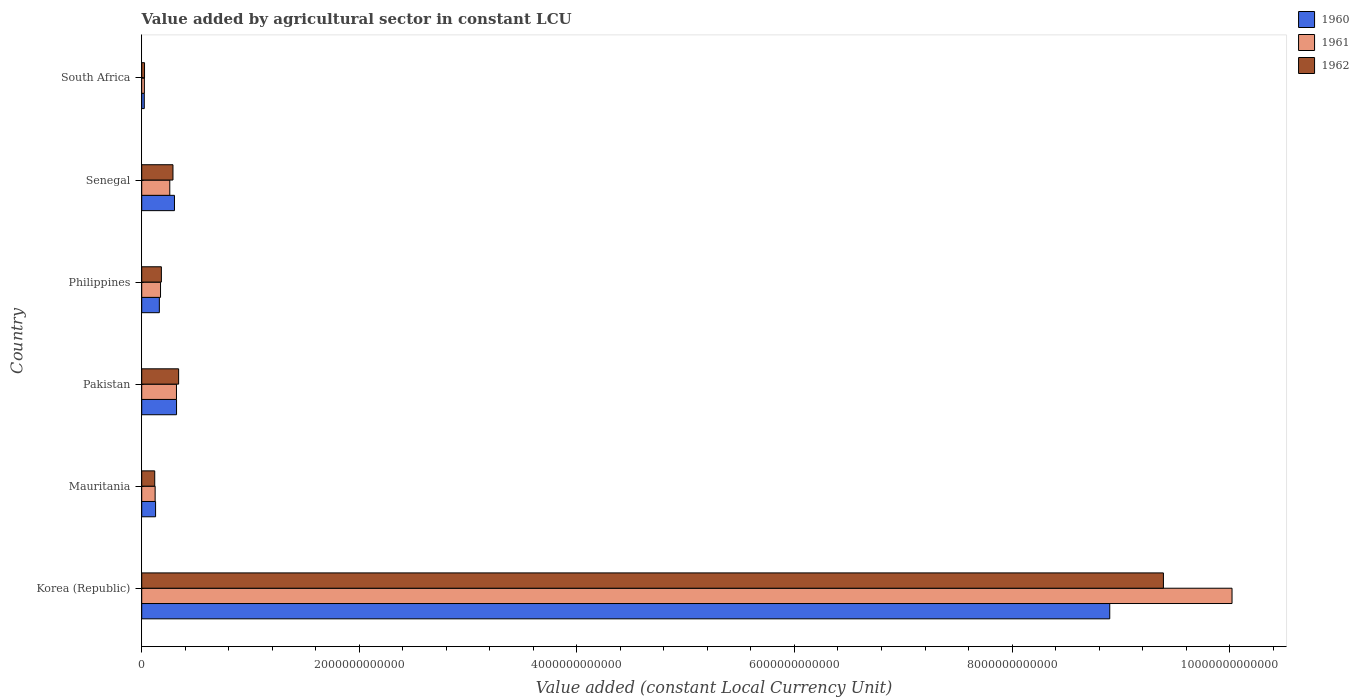How many different coloured bars are there?
Provide a short and direct response. 3. Are the number of bars per tick equal to the number of legend labels?
Offer a terse response. Yes. Are the number of bars on each tick of the Y-axis equal?
Offer a very short reply. Yes. How many bars are there on the 6th tick from the top?
Make the answer very short. 3. What is the label of the 6th group of bars from the top?
Offer a terse response. Korea (Republic). In how many cases, is the number of bars for a given country not equal to the number of legend labels?
Offer a terse response. 0. What is the value added by agricultural sector in 1960 in South Africa?
Offer a terse response. 2.36e+1. Across all countries, what is the maximum value added by agricultural sector in 1960?
Provide a short and direct response. 8.90e+12. Across all countries, what is the minimum value added by agricultural sector in 1962?
Offer a very short reply. 2.58e+1. In which country was the value added by agricultural sector in 1961 maximum?
Offer a very short reply. Korea (Republic). In which country was the value added by agricultural sector in 1961 minimum?
Provide a succinct answer. South Africa. What is the total value added by agricultural sector in 1962 in the graph?
Offer a very short reply. 1.03e+13. What is the difference between the value added by agricultural sector in 1961 in Korea (Republic) and that in Philippines?
Provide a short and direct response. 9.85e+12. What is the difference between the value added by agricultural sector in 1962 in Pakistan and the value added by agricultural sector in 1960 in Senegal?
Give a very brief answer. 3.82e+1. What is the average value added by agricultural sector in 1961 per country?
Your answer should be very brief. 1.82e+12. What is the difference between the value added by agricultural sector in 1960 and value added by agricultural sector in 1962 in Korea (Republic)?
Make the answer very short. -4.93e+11. In how many countries, is the value added by agricultural sector in 1961 greater than 7200000000000 LCU?
Offer a very short reply. 1. What is the ratio of the value added by agricultural sector in 1962 in Philippines to that in South Africa?
Provide a short and direct response. 7. Is the value added by agricultural sector in 1961 in Korea (Republic) less than that in Mauritania?
Provide a short and direct response. No. What is the difference between the highest and the second highest value added by agricultural sector in 1961?
Offer a terse response. 9.70e+12. What is the difference between the highest and the lowest value added by agricultural sector in 1962?
Offer a very short reply. 9.37e+12. What does the 1st bar from the top in Philippines represents?
Your answer should be compact. 1962. What does the 2nd bar from the bottom in Korea (Republic) represents?
Provide a succinct answer. 1961. Is it the case that in every country, the sum of the value added by agricultural sector in 1961 and value added by agricultural sector in 1960 is greater than the value added by agricultural sector in 1962?
Give a very brief answer. Yes. How many bars are there?
Provide a short and direct response. 18. Are all the bars in the graph horizontal?
Make the answer very short. Yes. How many countries are there in the graph?
Your answer should be very brief. 6. What is the difference between two consecutive major ticks on the X-axis?
Ensure brevity in your answer.  2.00e+12. Does the graph contain grids?
Offer a very short reply. No. What is the title of the graph?
Provide a short and direct response. Value added by agricultural sector in constant LCU. Does "1972" appear as one of the legend labels in the graph?
Your response must be concise. No. What is the label or title of the X-axis?
Offer a very short reply. Value added (constant Local Currency Unit). What is the Value added (constant Local Currency Unit) in 1960 in Korea (Republic)?
Offer a terse response. 8.90e+12. What is the Value added (constant Local Currency Unit) in 1961 in Korea (Republic)?
Your response must be concise. 1.00e+13. What is the Value added (constant Local Currency Unit) in 1962 in Korea (Republic)?
Provide a succinct answer. 9.39e+12. What is the Value added (constant Local Currency Unit) of 1960 in Mauritania?
Make the answer very short. 1.27e+11. What is the Value added (constant Local Currency Unit) of 1961 in Mauritania?
Give a very brief answer. 1.23e+11. What is the Value added (constant Local Currency Unit) of 1962 in Mauritania?
Ensure brevity in your answer.  1.20e+11. What is the Value added (constant Local Currency Unit) in 1960 in Pakistan?
Give a very brief answer. 3.20e+11. What is the Value added (constant Local Currency Unit) of 1961 in Pakistan?
Make the answer very short. 3.19e+11. What is the Value added (constant Local Currency Unit) of 1962 in Pakistan?
Provide a short and direct response. 3.39e+11. What is the Value added (constant Local Currency Unit) of 1960 in Philippines?
Ensure brevity in your answer.  1.62e+11. What is the Value added (constant Local Currency Unit) of 1961 in Philippines?
Your answer should be compact. 1.73e+11. What is the Value added (constant Local Currency Unit) of 1962 in Philippines?
Give a very brief answer. 1.81e+11. What is the Value added (constant Local Currency Unit) in 1960 in Senegal?
Your response must be concise. 3.01e+11. What is the Value added (constant Local Currency Unit) of 1961 in Senegal?
Offer a very short reply. 2.58e+11. What is the Value added (constant Local Currency Unit) of 1962 in Senegal?
Give a very brief answer. 2.87e+11. What is the Value added (constant Local Currency Unit) of 1960 in South Africa?
Your response must be concise. 2.36e+1. What is the Value added (constant Local Currency Unit) of 1961 in South Africa?
Your response must be concise. 2.44e+1. What is the Value added (constant Local Currency Unit) in 1962 in South Africa?
Keep it short and to the point. 2.58e+1. Across all countries, what is the maximum Value added (constant Local Currency Unit) in 1960?
Keep it short and to the point. 8.90e+12. Across all countries, what is the maximum Value added (constant Local Currency Unit) of 1961?
Provide a succinct answer. 1.00e+13. Across all countries, what is the maximum Value added (constant Local Currency Unit) in 1962?
Your response must be concise. 9.39e+12. Across all countries, what is the minimum Value added (constant Local Currency Unit) of 1960?
Keep it short and to the point. 2.36e+1. Across all countries, what is the minimum Value added (constant Local Currency Unit) in 1961?
Keep it short and to the point. 2.44e+1. Across all countries, what is the minimum Value added (constant Local Currency Unit) of 1962?
Offer a terse response. 2.58e+1. What is the total Value added (constant Local Currency Unit) in 1960 in the graph?
Offer a very short reply. 9.83e+12. What is the total Value added (constant Local Currency Unit) of 1961 in the graph?
Make the answer very short. 1.09e+13. What is the total Value added (constant Local Currency Unit) in 1962 in the graph?
Keep it short and to the point. 1.03e+13. What is the difference between the Value added (constant Local Currency Unit) of 1960 in Korea (Republic) and that in Mauritania?
Ensure brevity in your answer.  8.77e+12. What is the difference between the Value added (constant Local Currency Unit) of 1961 in Korea (Republic) and that in Mauritania?
Make the answer very short. 9.90e+12. What is the difference between the Value added (constant Local Currency Unit) in 1962 in Korea (Republic) and that in Mauritania?
Provide a succinct answer. 9.27e+12. What is the difference between the Value added (constant Local Currency Unit) in 1960 in Korea (Republic) and that in Pakistan?
Your answer should be very brief. 8.58e+12. What is the difference between the Value added (constant Local Currency Unit) in 1961 in Korea (Republic) and that in Pakistan?
Your answer should be compact. 9.70e+12. What is the difference between the Value added (constant Local Currency Unit) in 1962 in Korea (Republic) and that in Pakistan?
Give a very brief answer. 9.05e+12. What is the difference between the Value added (constant Local Currency Unit) in 1960 in Korea (Republic) and that in Philippines?
Keep it short and to the point. 8.74e+12. What is the difference between the Value added (constant Local Currency Unit) in 1961 in Korea (Republic) and that in Philippines?
Offer a terse response. 9.85e+12. What is the difference between the Value added (constant Local Currency Unit) in 1962 in Korea (Republic) and that in Philippines?
Provide a succinct answer. 9.21e+12. What is the difference between the Value added (constant Local Currency Unit) of 1960 in Korea (Republic) and that in Senegal?
Your answer should be very brief. 8.60e+12. What is the difference between the Value added (constant Local Currency Unit) in 1961 in Korea (Republic) and that in Senegal?
Provide a short and direct response. 9.76e+12. What is the difference between the Value added (constant Local Currency Unit) in 1962 in Korea (Republic) and that in Senegal?
Give a very brief answer. 9.10e+12. What is the difference between the Value added (constant Local Currency Unit) of 1960 in Korea (Republic) and that in South Africa?
Provide a succinct answer. 8.87e+12. What is the difference between the Value added (constant Local Currency Unit) of 1961 in Korea (Republic) and that in South Africa?
Your answer should be very brief. 1.00e+13. What is the difference between the Value added (constant Local Currency Unit) in 1962 in Korea (Republic) and that in South Africa?
Offer a terse response. 9.37e+12. What is the difference between the Value added (constant Local Currency Unit) in 1960 in Mauritania and that in Pakistan?
Offer a terse response. -1.93e+11. What is the difference between the Value added (constant Local Currency Unit) of 1961 in Mauritania and that in Pakistan?
Ensure brevity in your answer.  -1.96e+11. What is the difference between the Value added (constant Local Currency Unit) in 1962 in Mauritania and that in Pakistan?
Offer a very short reply. -2.20e+11. What is the difference between the Value added (constant Local Currency Unit) of 1960 in Mauritania and that in Philippines?
Ensure brevity in your answer.  -3.47e+1. What is the difference between the Value added (constant Local Currency Unit) of 1961 in Mauritania and that in Philippines?
Make the answer very short. -4.95e+1. What is the difference between the Value added (constant Local Currency Unit) in 1962 in Mauritania and that in Philippines?
Make the answer very short. -6.11e+1. What is the difference between the Value added (constant Local Currency Unit) in 1960 in Mauritania and that in Senegal?
Keep it short and to the point. -1.74e+11. What is the difference between the Value added (constant Local Currency Unit) of 1961 in Mauritania and that in Senegal?
Offer a very short reply. -1.35e+11. What is the difference between the Value added (constant Local Currency Unit) of 1962 in Mauritania and that in Senegal?
Make the answer very short. -1.68e+11. What is the difference between the Value added (constant Local Currency Unit) in 1960 in Mauritania and that in South Africa?
Provide a succinct answer. 1.04e+11. What is the difference between the Value added (constant Local Currency Unit) of 1961 in Mauritania and that in South Africa?
Ensure brevity in your answer.  9.88e+1. What is the difference between the Value added (constant Local Currency Unit) of 1962 in Mauritania and that in South Africa?
Provide a succinct answer. 9.38e+1. What is the difference between the Value added (constant Local Currency Unit) in 1960 in Pakistan and that in Philippines?
Your answer should be compact. 1.58e+11. What is the difference between the Value added (constant Local Currency Unit) in 1961 in Pakistan and that in Philippines?
Give a very brief answer. 1.47e+11. What is the difference between the Value added (constant Local Currency Unit) of 1962 in Pakistan and that in Philippines?
Offer a terse response. 1.58e+11. What is the difference between the Value added (constant Local Currency Unit) in 1960 in Pakistan and that in Senegal?
Keep it short and to the point. 1.91e+1. What is the difference between the Value added (constant Local Currency Unit) in 1961 in Pakistan and that in Senegal?
Ensure brevity in your answer.  6.16e+1. What is the difference between the Value added (constant Local Currency Unit) of 1962 in Pakistan and that in Senegal?
Your answer should be very brief. 5.20e+1. What is the difference between the Value added (constant Local Currency Unit) in 1960 in Pakistan and that in South Africa?
Offer a terse response. 2.97e+11. What is the difference between the Value added (constant Local Currency Unit) in 1961 in Pakistan and that in South Africa?
Provide a succinct answer. 2.95e+11. What is the difference between the Value added (constant Local Currency Unit) of 1962 in Pakistan and that in South Africa?
Ensure brevity in your answer.  3.13e+11. What is the difference between the Value added (constant Local Currency Unit) of 1960 in Philippines and that in Senegal?
Make the answer very short. -1.39e+11. What is the difference between the Value added (constant Local Currency Unit) of 1961 in Philippines and that in Senegal?
Ensure brevity in your answer.  -8.50e+1. What is the difference between the Value added (constant Local Currency Unit) in 1962 in Philippines and that in Senegal?
Offer a very short reply. -1.07e+11. What is the difference between the Value added (constant Local Currency Unit) of 1960 in Philippines and that in South Africa?
Give a very brief answer. 1.38e+11. What is the difference between the Value added (constant Local Currency Unit) in 1961 in Philippines and that in South Africa?
Ensure brevity in your answer.  1.48e+11. What is the difference between the Value added (constant Local Currency Unit) of 1962 in Philippines and that in South Africa?
Your answer should be compact. 1.55e+11. What is the difference between the Value added (constant Local Currency Unit) of 1960 in Senegal and that in South Africa?
Offer a terse response. 2.77e+11. What is the difference between the Value added (constant Local Currency Unit) in 1961 in Senegal and that in South Africa?
Offer a terse response. 2.33e+11. What is the difference between the Value added (constant Local Currency Unit) of 1962 in Senegal and that in South Africa?
Provide a succinct answer. 2.61e+11. What is the difference between the Value added (constant Local Currency Unit) in 1960 in Korea (Republic) and the Value added (constant Local Currency Unit) in 1961 in Mauritania?
Keep it short and to the point. 8.77e+12. What is the difference between the Value added (constant Local Currency Unit) of 1960 in Korea (Republic) and the Value added (constant Local Currency Unit) of 1962 in Mauritania?
Ensure brevity in your answer.  8.78e+12. What is the difference between the Value added (constant Local Currency Unit) in 1961 in Korea (Republic) and the Value added (constant Local Currency Unit) in 1962 in Mauritania?
Offer a very short reply. 9.90e+12. What is the difference between the Value added (constant Local Currency Unit) in 1960 in Korea (Republic) and the Value added (constant Local Currency Unit) in 1961 in Pakistan?
Keep it short and to the point. 8.58e+12. What is the difference between the Value added (constant Local Currency Unit) in 1960 in Korea (Republic) and the Value added (constant Local Currency Unit) in 1962 in Pakistan?
Keep it short and to the point. 8.56e+12. What is the difference between the Value added (constant Local Currency Unit) of 1961 in Korea (Republic) and the Value added (constant Local Currency Unit) of 1962 in Pakistan?
Your answer should be compact. 9.68e+12. What is the difference between the Value added (constant Local Currency Unit) in 1960 in Korea (Republic) and the Value added (constant Local Currency Unit) in 1961 in Philippines?
Offer a terse response. 8.73e+12. What is the difference between the Value added (constant Local Currency Unit) of 1960 in Korea (Republic) and the Value added (constant Local Currency Unit) of 1962 in Philippines?
Offer a terse response. 8.72e+12. What is the difference between the Value added (constant Local Currency Unit) in 1961 in Korea (Republic) and the Value added (constant Local Currency Unit) in 1962 in Philippines?
Offer a terse response. 9.84e+12. What is the difference between the Value added (constant Local Currency Unit) in 1960 in Korea (Republic) and the Value added (constant Local Currency Unit) in 1961 in Senegal?
Offer a very short reply. 8.64e+12. What is the difference between the Value added (constant Local Currency Unit) in 1960 in Korea (Republic) and the Value added (constant Local Currency Unit) in 1962 in Senegal?
Make the answer very short. 8.61e+12. What is the difference between the Value added (constant Local Currency Unit) of 1961 in Korea (Republic) and the Value added (constant Local Currency Unit) of 1962 in Senegal?
Provide a short and direct response. 9.73e+12. What is the difference between the Value added (constant Local Currency Unit) in 1960 in Korea (Republic) and the Value added (constant Local Currency Unit) in 1961 in South Africa?
Make the answer very short. 8.87e+12. What is the difference between the Value added (constant Local Currency Unit) in 1960 in Korea (Republic) and the Value added (constant Local Currency Unit) in 1962 in South Africa?
Offer a very short reply. 8.87e+12. What is the difference between the Value added (constant Local Currency Unit) in 1961 in Korea (Republic) and the Value added (constant Local Currency Unit) in 1962 in South Africa?
Make the answer very short. 1.00e+13. What is the difference between the Value added (constant Local Currency Unit) in 1960 in Mauritania and the Value added (constant Local Currency Unit) in 1961 in Pakistan?
Provide a succinct answer. -1.92e+11. What is the difference between the Value added (constant Local Currency Unit) in 1960 in Mauritania and the Value added (constant Local Currency Unit) in 1962 in Pakistan?
Offer a terse response. -2.12e+11. What is the difference between the Value added (constant Local Currency Unit) in 1961 in Mauritania and the Value added (constant Local Currency Unit) in 1962 in Pakistan?
Your answer should be very brief. -2.16e+11. What is the difference between the Value added (constant Local Currency Unit) in 1960 in Mauritania and the Value added (constant Local Currency Unit) in 1961 in Philippines?
Give a very brief answer. -4.55e+1. What is the difference between the Value added (constant Local Currency Unit) of 1960 in Mauritania and the Value added (constant Local Currency Unit) of 1962 in Philippines?
Your answer should be very brief. -5.34e+1. What is the difference between the Value added (constant Local Currency Unit) of 1961 in Mauritania and the Value added (constant Local Currency Unit) of 1962 in Philippines?
Keep it short and to the point. -5.74e+1. What is the difference between the Value added (constant Local Currency Unit) in 1960 in Mauritania and the Value added (constant Local Currency Unit) in 1961 in Senegal?
Your answer should be very brief. -1.31e+11. What is the difference between the Value added (constant Local Currency Unit) of 1960 in Mauritania and the Value added (constant Local Currency Unit) of 1962 in Senegal?
Provide a succinct answer. -1.60e+11. What is the difference between the Value added (constant Local Currency Unit) of 1961 in Mauritania and the Value added (constant Local Currency Unit) of 1962 in Senegal?
Ensure brevity in your answer.  -1.64e+11. What is the difference between the Value added (constant Local Currency Unit) in 1960 in Mauritania and the Value added (constant Local Currency Unit) in 1961 in South Africa?
Your answer should be compact. 1.03e+11. What is the difference between the Value added (constant Local Currency Unit) of 1960 in Mauritania and the Value added (constant Local Currency Unit) of 1962 in South Africa?
Keep it short and to the point. 1.01e+11. What is the difference between the Value added (constant Local Currency Unit) in 1961 in Mauritania and the Value added (constant Local Currency Unit) in 1962 in South Africa?
Make the answer very short. 9.75e+1. What is the difference between the Value added (constant Local Currency Unit) in 1960 in Pakistan and the Value added (constant Local Currency Unit) in 1961 in Philippines?
Make the answer very short. 1.47e+11. What is the difference between the Value added (constant Local Currency Unit) of 1960 in Pakistan and the Value added (constant Local Currency Unit) of 1962 in Philippines?
Your answer should be very brief. 1.39e+11. What is the difference between the Value added (constant Local Currency Unit) of 1961 in Pakistan and the Value added (constant Local Currency Unit) of 1962 in Philippines?
Offer a terse response. 1.39e+11. What is the difference between the Value added (constant Local Currency Unit) of 1960 in Pakistan and the Value added (constant Local Currency Unit) of 1961 in Senegal?
Your answer should be very brief. 6.22e+1. What is the difference between the Value added (constant Local Currency Unit) of 1960 in Pakistan and the Value added (constant Local Currency Unit) of 1962 in Senegal?
Provide a succinct answer. 3.29e+1. What is the difference between the Value added (constant Local Currency Unit) in 1961 in Pakistan and the Value added (constant Local Currency Unit) in 1962 in Senegal?
Your response must be concise. 3.22e+1. What is the difference between the Value added (constant Local Currency Unit) of 1960 in Pakistan and the Value added (constant Local Currency Unit) of 1961 in South Africa?
Your answer should be very brief. 2.96e+11. What is the difference between the Value added (constant Local Currency Unit) of 1960 in Pakistan and the Value added (constant Local Currency Unit) of 1962 in South Africa?
Offer a very short reply. 2.94e+11. What is the difference between the Value added (constant Local Currency Unit) of 1961 in Pakistan and the Value added (constant Local Currency Unit) of 1962 in South Africa?
Offer a terse response. 2.94e+11. What is the difference between the Value added (constant Local Currency Unit) in 1960 in Philippines and the Value added (constant Local Currency Unit) in 1961 in Senegal?
Make the answer very short. -9.59e+1. What is the difference between the Value added (constant Local Currency Unit) in 1960 in Philippines and the Value added (constant Local Currency Unit) in 1962 in Senegal?
Make the answer very short. -1.25e+11. What is the difference between the Value added (constant Local Currency Unit) in 1961 in Philippines and the Value added (constant Local Currency Unit) in 1962 in Senegal?
Make the answer very short. -1.14e+11. What is the difference between the Value added (constant Local Currency Unit) in 1960 in Philippines and the Value added (constant Local Currency Unit) in 1961 in South Africa?
Your answer should be very brief. 1.38e+11. What is the difference between the Value added (constant Local Currency Unit) of 1960 in Philippines and the Value added (constant Local Currency Unit) of 1962 in South Africa?
Provide a succinct answer. 1.36e+11. What is the difference between the Value added (constant Local Currency Unit) in 1961 in Philippines and the Value added (constant Local Currency Unit) in 1962 in South Africa?
Offer a very short reply. 1.47e+11. What is the difference between the Value added (constant Local Currency Unit) of 1960 in Senegal and the Value added (constant Local Currency Unit) of 1961 in South Africa?
Provide a succinct answer. 2.77e+11. What is the difference between the Value added (constant Local Currency Unit) of 1960 in Senegal and the Value added (constant Local Currency Unit) of 1962 in South Africa?
Keep it short and to the point. 2.75e+11. What is the difference between the Value added (constant Local Currency Unit) in 1961 in Senegal and the Value added (constant Local Currency Unit) in 1962 in South Africa?
Give a very brief answer. 2.32e+11. What is the average Value added (constant Local Currency Unit) in 1960 per country?
Make the answer very short. 1.64e+12. What is the average Value added (constant Local Currency Unit) of 1961 per country?
Make the answer very short. 1.82e+12. What is the average Value added (constant Local Currency Unit) in 1962 per country?
Your answer should be compact. 1.72e+12. What is the difference between the Value added (constant Local Currency Unit) of 1960 and Value added (constant Local Currency Unit) of 1961 in Korea (Republic)?
Your answer should be very brief. -1.12e+12. What is the difference between the Value added (constant Local Currency Unit) of 1960 and Value added (constant Local Currency Unit) of 1962 in Korea (Republic)?
Provide a succinct answer. -4.93e+11. What is the difference between the Value added (constant Local Currency Unit) of 1961 and Value added (constant Local Currency Unit) of 1962 in Korea (Republic)?
Make the answer very short. 6.31e+11. What is the difference between the Value added (constant Local Currency Unit) in 1960 and Value added (constant Local Currency Unit) in 1961 in Mauritania?
Make the answer very short. 4.01e+09. What is the difference between the Value added (constant Local Currency Unit) of 1960 and Value added (constant Local Currency Unit) of 1962 in Mauritania?
Offer a terse response. 7.67e+09. What is the difference between the Value added (constant Local Currency Unit) of 1961 and Value added (constant Local Currency Unit) of 1962 in Mauritania?
Keep it short and to the point. 3.65e+09. What is the difference between the Value added (constant Local Currency Unit) in 1960 and Value added (constant Local Currency Unit) in 1961 in Pakistan?
Your response must be concise. 6.46e+08. What is the difference between the Value added (constant Local Currency Unit) in 1960 and Value added (constant Local Currency Unit) in 1962 in Pakistan?
Offer a terse response. -1.91e+1. What is the difference between the Value added (constant Local Currency Unit) of 1961 and Value added (constant Local Currency Unit) of 1962 in Pakistan?
Your answer should be compact. -1.97e+1. What is the difference between the Value added (constant Local Currency Unit) in 1960 and Value added (constant Local Currency Unit) in 1961 in Philippines?
Provide a succinct answer. -1.08e+1. What is the difference between the Value added (constant Local Currency Unit) in 1960 and Value added (constant Local Currency Unit) in 1962 in Philippines?
Provide a short and direct response. -1.87e+1. What is the difference between the Value added (constant Local Currency Unit) of 1961 and Value added (constant Local Currency Unit) of 1962 in Philippines?
Offer a terse response. -7.86e+09. What is the difference between the Value added (constant Local Currency Unit) of 1960 and Value added (constant Local Currency Unit) of 1961 in Senegal?
Provide a succinct answer. 4.31e+1. What is the difference between the Value added (constant Local Currency Unit) in 1960 and Value added (constant Local Currency Unit) in 1962 in Senegal?
Make the answer very short. 1.38e+1. What is the difference between the Value added (constant Local Currency Unit) in 1961 and Value added (constant Local Currency Unit) in 1962 in Senegal?
Offer a terse response. -2.93e+1. What is the difference between the Value added (constant Local Currency Unit) in 1960 and Value added (constant Local Currency Unit) in 1961 in South Africa?
Your answer should be very brief. -8.75e+08. What is the difference between the Value added (constant Local Currency Unit) of 1960 and Value added (constant Local Currency Unit) of 1962 in South Africa?
Offer a very short reply. -2.26e+09. What is the difference between the Value added (constant Local Currency Unit) in 1961 and Value added (constant Local Currency Unit) in 1962 in South Africa?
Provide a short and direct response. -1.39e+09. What is the ratio of the Value added (constant Local Currency Unit) in 1960 in Korea (Republic) to that in Mauritania?
Provide a succinct answer. 69.9. What is the ratio of the Value added (constant Local Currency Unit) in 1961 in Korea (Republic) to that in Mauritania?
Your answer should be compact. 81.29. What is the ratio of the Value added (constant Local Currency Unit) in 1962 in Korea (Republic) to that in Mauritania?
Offer a terse response. 78.51. What is the ratio of the Value added (constant Local Currency Unit) in 1960 in Korea (Republic) to that in Pakistan?
Offer a very short reply. 27.8. What is the ratio of the Value added (constant Local Currency Unit) in 1961 in Korea (Republic) to that in Pakistan?
Provide a succinct answer. 31.38. What is the ratio of the Value added (constant Local Currency Unit) of 1962 in Korea (Republic) to that in Pakistan?
Your answer should be compact. 27.69. What is the ratio of the Value added (constant Local Currency Unit) of 1960 in Korea (Republic) to that in Philippines?
Make the answer very short. 54.93. What is the ratio of the Value added (constant Local Currency Unit) in 1961 in Korea (Republic) to that in Philippines?
Your answer should be compact. 57.99. What is the ratio of the Value added (constant Local Currency Unit) of 1962 in Korea (Republic) to that in Philippines?
Offer a terse response. 51.98. What is the ratio of the Value added (constant Local Currency Unit) of 1960 in Korea (Republic) to that in Senegal?
Give a very brief answer. 29.57. What is the ratio of the Value added (constant Local Currency Unit) in 1961 in Korea (Republic) to that in Senegal?
Give a very brief answer. 38.87. What is the ratio of the Value added (constant Local Currency Unit) in 1962 in Korea (Republic) to that in Senegal?
Give a very brief answer. 32.7. What is the ratio of the Value added (constant Local Currency Unit) of 1960 in Korea (Republic) to that in South Africa?
Offer a very short reply. 377.7. What is the ratio of the Value added (constant Local Currency Unit) in 1961 in Korea (Republic) to that in South Africa?
Offer a very short reply. 410.18. What is the ratio of the Value added (constant Local Currency Unit) of 1962 in Korea (Republic) to that in South Africa?
Keep it short and to the point. 363.73. What is the ratio of the Value added (constant Local Currency Unit) of 1960 in Mauritania to that in Pakistan?
Make the answer very short. 0.4. What is the ratio of the Value added (constant Local Currency Unit) of 1961 in Mauritania to that in Pakistan?
Your response must be concise. 0.39. What is the ratio of the Value added (constant Local Currency Unit) in 1962 in Mauritania to that in Pakistan?
Your answer should be compact. 0.35. What is the ratio of the Value added (constant Local Currency Unit) in 1960 in Mauritania to that in Philippines?
Give a very brief answer. 0.79. What is the ratio of the Value added (constant Local Currency Unit) in 1961 in Mauritania to that in Philippines?
Offer a terse response. 0.71. What is the ratio of the Value added (constant Local Currency Unit) of 1962 in Mauritania to that in Philippines?
Your answer should be very brief. 0.66. What is the ratio of the Value added (constant Local Currency Unit) in 1960 in Mauritania to that in Senegal?
Your answer should be compact. 0.42. What is the ratio of the Value added (constant Local Currency Unit) in 1961 in Mauritania to that in Senegal?
Offer a terse response. 0.48. What is the ratio of the Value added (constant Local Currency Unit) in 1962 in Mauritania to that in Senegal?
Provide a short and direct response. 0.42. What is the ratio of the Value added (constant Local Currency Unit) in 1960 in Mauritania to that in South Africa?
Give a very brief answer. 5.4. What is the ratio of the Value added (constant Local Currency Unit) in 1961 in Mauritania to that in South Africa?
Keep it short and to the point. 5.05. What is the ratio of the Value added (constant Local Currency Unit) in 1962 in Mauritania to that in South Africa?
Offer a terse response. 4.63. What is the ratio of the Value added (constant Local Currency Unit) of 1960 in Pakistan to that in Philippines?
Ensure brevity in your answer.  1.98. What is the ratio of the Value added (constant Local Currency Unit) of 1961 in Pakistan to that in Philippines?
Your answer should be compact. 1.85. What is the ratio of the Value added (constant Local Currency Unit) in 1962 in Pakistan to that in Philippines?
Provide a short and direct response. 1.88. What is the ratio of the Value added (constant Local Currency Unit) in 1960 in Pakistan to that in Senegal?
Keep it short and to the point. 1.06. What is the ratio of the Value added (constant Local Currency Unit) of 1961 in Pakistan to that in Senegal?
Your answer should be compact. 1.24. What is the ratio of the Value added (constant Local Currency Unit) of 1962 in Pakistan to that in Senegal?
Your answer should be compact. 1.18. What is the ratio of the Value added (constant Local Currency Unit) of 1960 in Pakistan to that in South Africa?
Your response must be concise. 13.59. What is the ratio of the Value added (constant Local Currency Unit) of 1961 in Pakistan to that in South Africa?
Ensure brevity in your answer.  13.07. What is the ratio of the Value added (constant Local Currency Unit) in 1962 in Pakistan to that in South Africa?
Offer a terse response. 13.14. What is the ratio of the Value added (constant Local Currency Unit) in 1960 in Philippines to that in Senegal?
Give a very brief answer. 0.54. What is the ratio of the Value added (constant Local Currency Unit) of 1961 in Philippines to that in Senegal?
Your answer should be compact. 0.67. What is the ratio of the Value added (constant Local Currency Unit) of 1962 in Philippines to that in Senegal?
Your answer should be compact. 0.63. What is the ratio of the Value added (constant Local Currency Unit) in 1960 in Philippines to that in South Africa?
Offer a terse response. 6.88. What is the ratio of the Value added (constant Local Currency Unit) of 1961 in Philippines to that in South Africa?
Make the answer very short. 7.07. What is the ratio of the Value added (constant Local Currency Unit) of 1962 in Philippines to that in South Africa?
Provide a short and direct response. 7. What is the ratio of the Value added (constant Local Currency Unit) in 1960 in Senegal to that in South Africa?
Your response must be concise. 12.77. What is the ratio of the Value added (constant Local Currency Unit) in 1961 in Senegal to that in South Africa?
Give a very brief answer. 10.55. What is the ratio of the Value added (constant Local Currency Unit) of 1962 in Senegal to that in South Africa?
Provide a succinct answer. 11.12. What is the difference between the highest and the second highest Value added (constant Local Currency Unit) in 1960?
Ensure brevity in your answer.  8.58e+12. What is the difference between the highest and the second highest Value added (constant Local Currency Unit) of 1961?
Provide a succinct answer. 9.70e+12. What is the difference between the highest and the second highest Value added (constant Local Currency Unit) in 1962?
Ensure brevity in your answer.  9.05e+12. What is the difference between the highest and the lowest Value added (constant Local Currency Unit) in 1960?
Provide a short and direct response. 8.87e+12. What is the difference between the highest and the lowest Value added (constant Local Currency Unit) of 1961?
Offer a terse response. 1.00e+13. What is the difference between the highest and the lowest Value added (constant Local Currency Unit) of 1962?
Provide a short and direct response. 9.37e+12. 